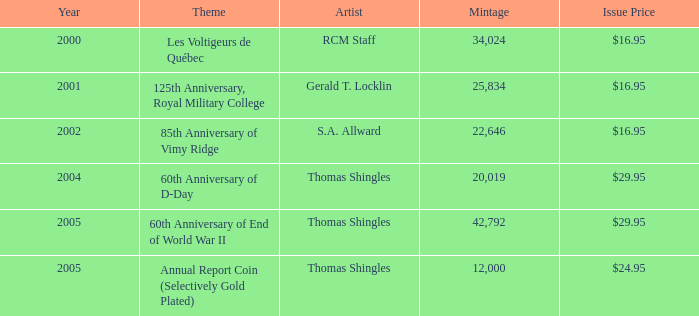In the years post-2002, what was the cumulative mintage of coins with an 85th anniversary of vimy ridge design? 0.0. 